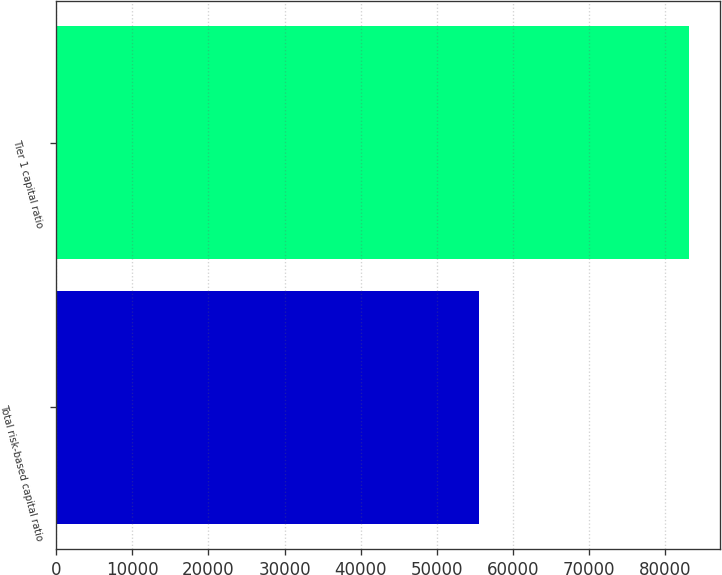Convert chart to OTSL. <chart><loc_0><loc_0><loc_500><loc_500><bar_chart><fcel>Total risk-based capital ratio<fcel>Tier 1 capital ratio<nl><fcel>55545<fcel>83030<nl></chart> 